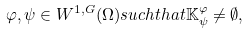Convert formula to latex. <formula><loc_0><loc_0><loc_500><loc_500>\varphi , \psi \in W ^ { 1 , G } ( \Omega ) s u c h t h a t \mathbb { K } _ { \psi } ^ { \varphi } \neq \emptyset ,</formula> 